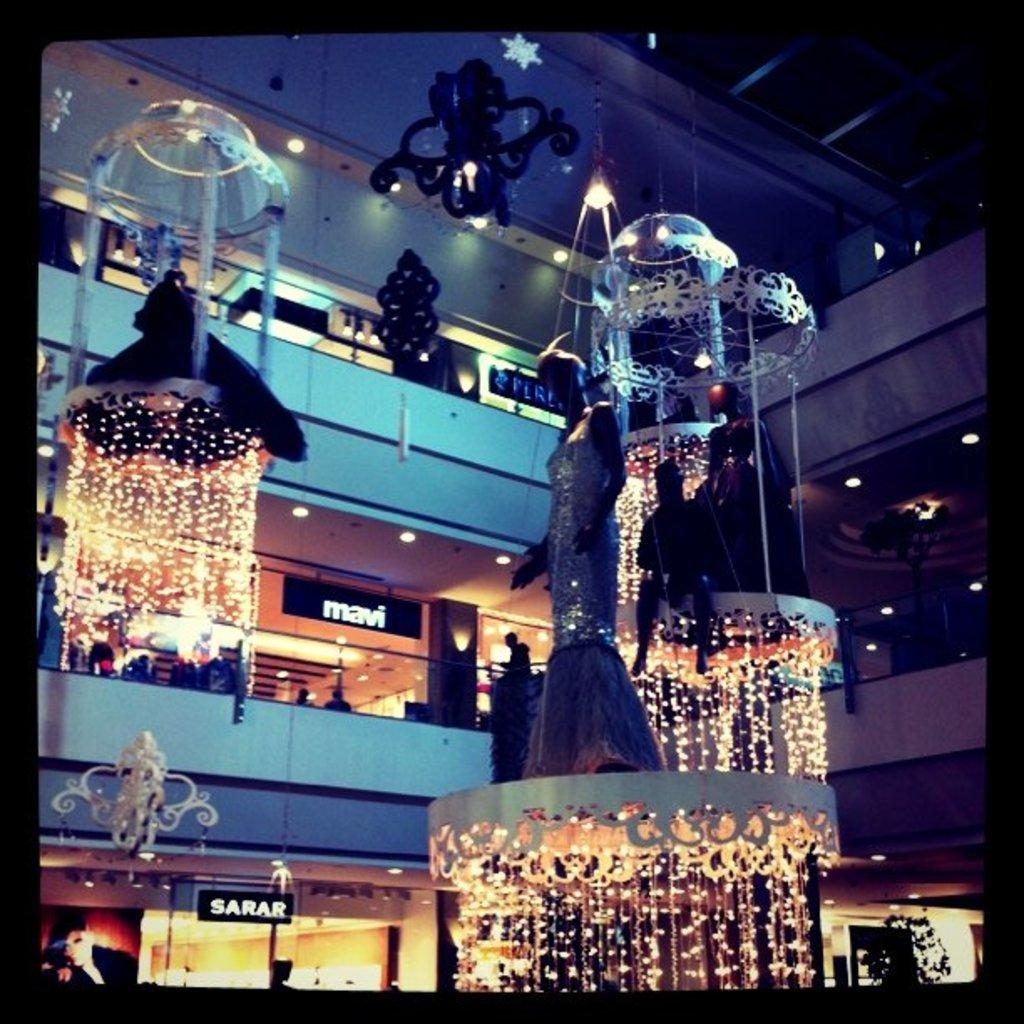What type of establishment is depicted in the image? The image shows a mall with shops. What type of lighting is present in the image? There are chandeliers and lights attached to the walls in the image. What decorative elements are hanging from the roof in the image? There are star symbols hanging from the roof in the image. What month is it in the image? The image does not provide any information about the month or time of year. What type of thread is used to hang the star symbols from the roof? The image does not provide any information about the type of thread used to hang the star symbols from the roof. 